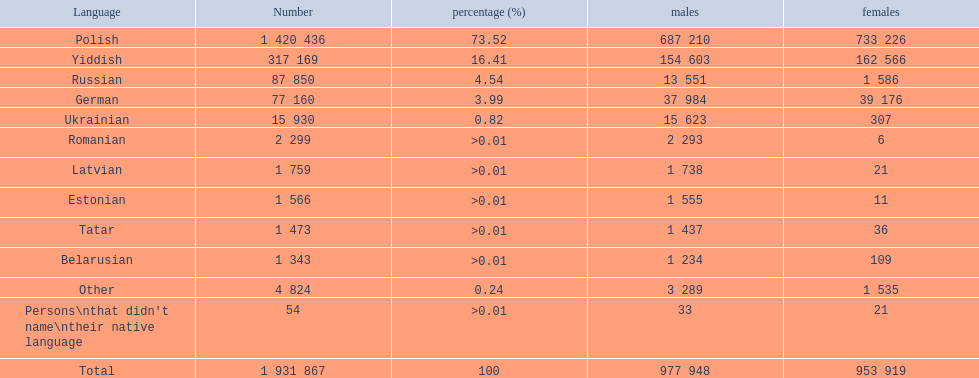Which languages are used by over 50,000 individuals? Polish, Yiddish, Russian, German. Among these languages, which ones are utilized by fewer than 15% of the populace? Russian, German. Of the remaining two, which one is employed by 37,984 males? German. 